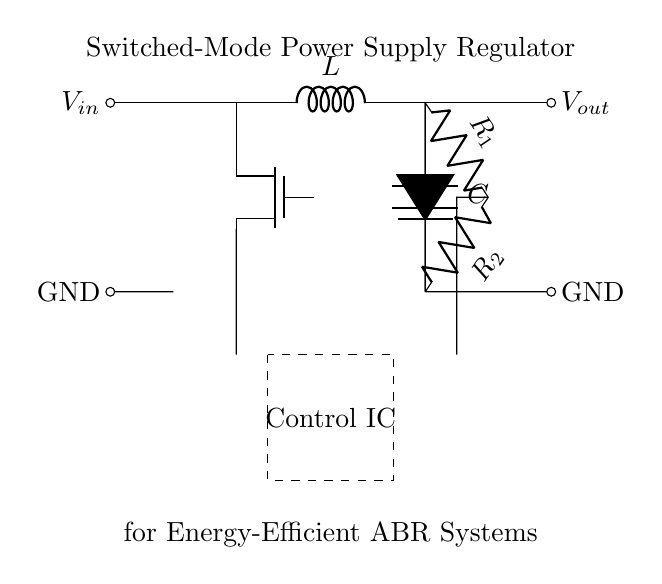What are the main components in this circuit? The circuit consists of a MOSFET, an inductor, a diode, a capacitor, resistors, and a control IC. These components work together to regulate voltage.
Answer: MOSFET, inductor, diode, capacitor, resistors, control IC What is the function of the inductor in this circuit? The inductor stores energy when current flows through it and releases it when the current is interrupted, smoothing the output current and voltage.
Answer: Energy storage What type of regulator is represented in this circuit? The circuit represents a switched-mode power supply regulator, which efficiently converts input voltage to a desired output voltage using switching elements.
Answer: Switched-mode power supply regulator What component is responsible for voltage regulation in this circuit? The control IC manages the operation of the MOSFET based on feedback from the output voltage, ensuring stable voltage regulation.
Answer: Control IC How do the feedback resistors function in this circuit? The feedback resistors create a voltage divider that helps the control IC determine the output voltage, allowing it to adjust the switching of the MOSFET for regulation.
Answer: Voltage divider What type of diode is used in this circuit? The circuit uses a Schottky diode, which is often chosen for its low forward voltage drop, enhancing efficiency in switched-mode power supplies.
Answer: Schottky diode 